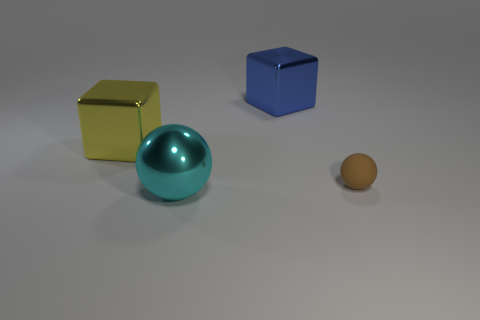Is there anything else that is the same size as the brown rubber sphere?
Offer a very short reply. No. There is a ball that is on the left side of the matte thing; is it the same size as the large yellow block?
Your answer should be compact. Yes. What is the material of the yellow thing that is the same size as the metal ball?
Give a very brief answer. Metal. Is there a tiny thing that is on the right side of the large cube in front of the block behind the yellow thing?
Offer a very short reply. Yes. Are there any other things that are the same shape as the small matte object?
Offer a very short reply. Yes. Does the sphere that is left of the big blue block have the same color as the object on the right side of the blue metallic thing?
Offer a terse response. No. Are there any metal blocks?
Your response must be concise. Yes. How big is the metallic block on the right side of the cube to the left of the ball that is to the left of the blue object?
Your answer should be very brief. Large. Does the large blue object have the same shape as the shiny thing that is left of the cyan sphere?
Provide a succinct answer. Yes. Is there a tiny thing of the same color as the rubber ball?
Provide a succinct answer. No. 